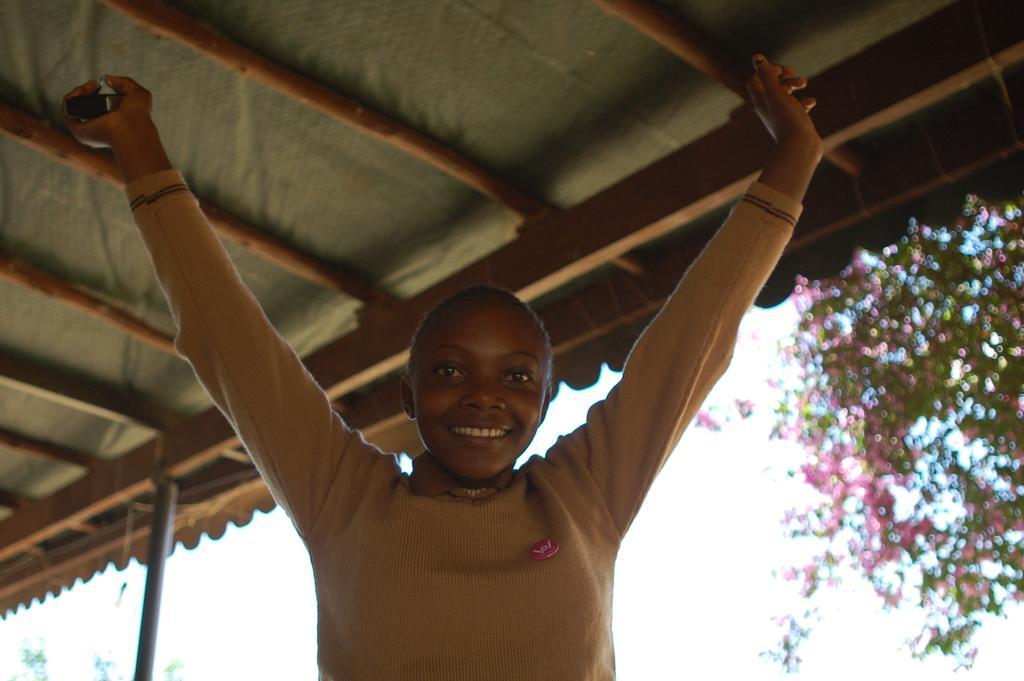In one or two sentences, can you explain what this image depicts? In this image we can see a woman. On the backside we can see a wooden roof, a plant with flowers and the sky which looks cloudy. 